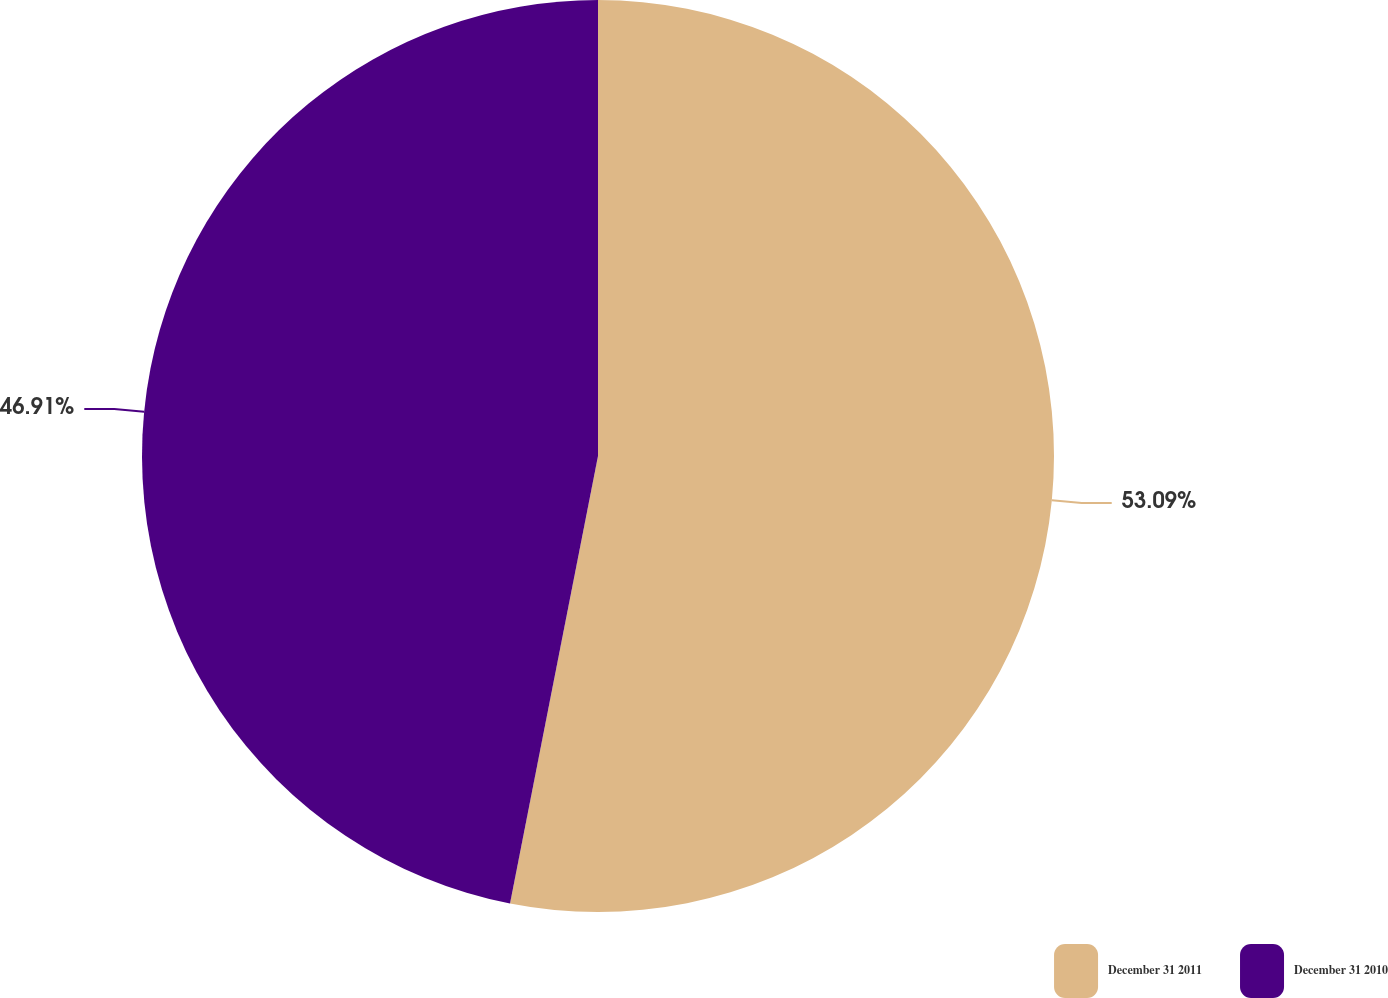<chart> <loc_0><loc_0><loc_500><loc_500><pie_chart><fcel>December 31 2011<fcel>December 31 2010<nl><fcel>53.09%<fcel>46.91%<nl></chart> 